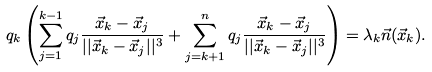<formula> <loc_0><loc_0><loc_500><loc_500>q _ { k } \left ( \sum _ { j = 1 } ^ { k - 1 } q _ { j } \frac { \vec { x } _ { k } - \vec { x } _ { j } } { | | \vec { x } _ { k } - \vec { x } _ { j } | | ^ { 3 } } + \sum _ { j = k + 1 } ^ { n } q _ { j } \frac { \vec { x } _ { k } - \vec { x } _ { j } } { | | \vec { x } _ { k } - \vec { x } _ { j } | | ^ { 3 } } \right ) = \lambda _ { k } \vec { n } ( \vec { x } _ { k } ) .</formula> 